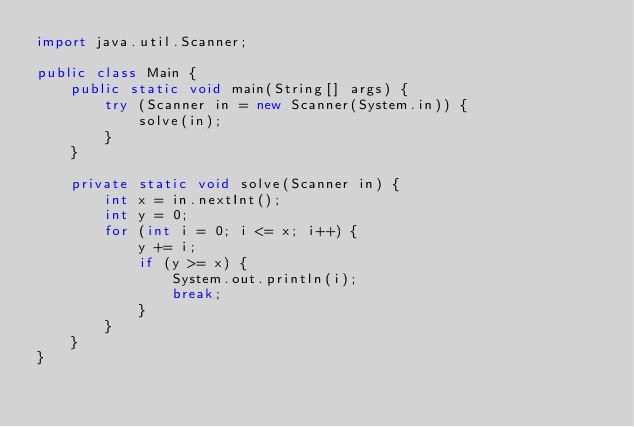Convert code to text. <code><loc_0><loc_0><loc_500><loc_500><_Java_>import java.util.Scanner;

public class Main {
    public static void main(String[] args) {
        try (Scanner in = new Scanner(System.in)) {
            solve(in);
        }
    }

    private static void solve(Scanner in) {
        int x = in.nextInt();
        int y = 0;
        for (int i = 0; i <= x; i++) {
            y += i;
            if (y >= x) {
                System.out.println(i);
                break;
            }
        }
    }
}
</code> 